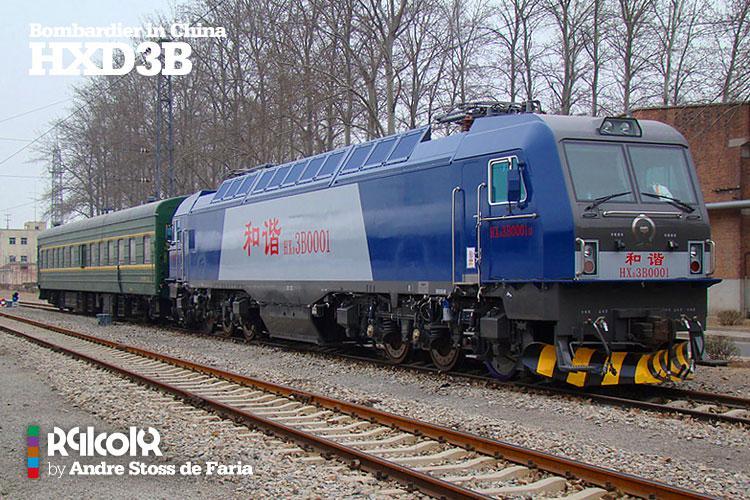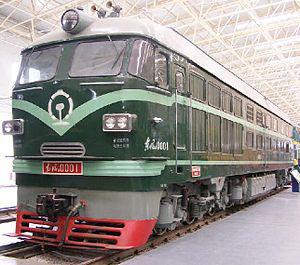The first image is the image on the left, the second image is the image on the right. Analyze the images presented: Is the assertion "The right image contains a train that is predominately blue." valid? Answer yes or no. No. The first image is the image on the left, the second image is the image on the right. Examine the images to the left and right. Is the description "The trains in the left and right images do not head in the same left or right direction, and at least one train is blue with a sloped front." accurate? Answer yes or no. Yes. 